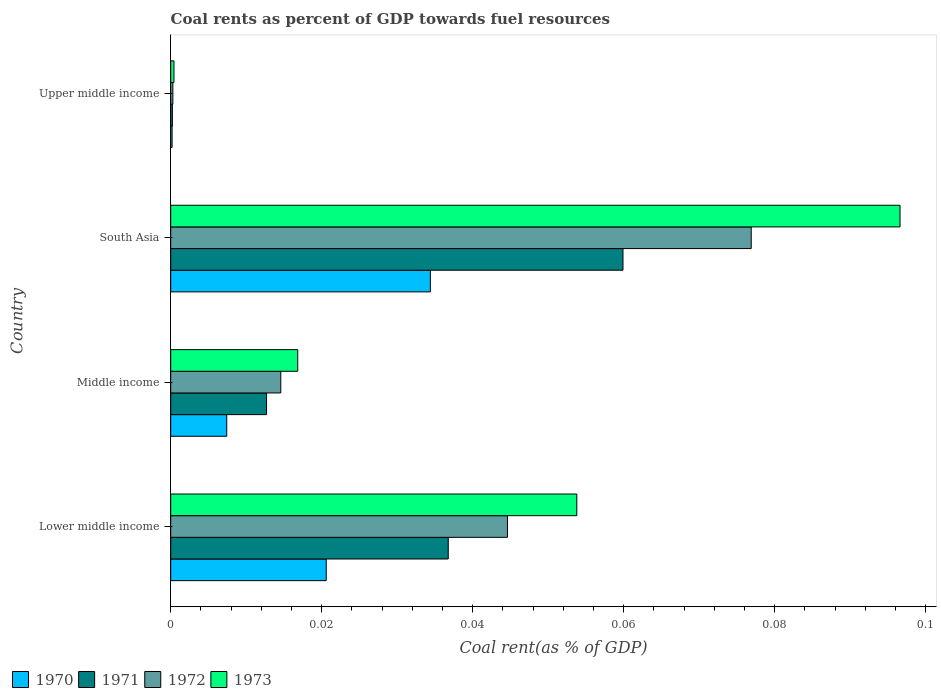How many different coloured bars are there?
Give a very brief answer. 4. How many groups of bars are there?
Your answer should be very brief. 4. Are the number of bars per tick equal to the number of legend labels?
Provide a short and direct response. Yes. How many bars are there on the 4th tick from the top?
Provide a succinct answer. 4. How many bars are there on the 4th tick from the bottom?
Keep it short and to the point. 4. What is the label of the 4th group of bars from the top?
Ensure brevity in your answer.  Lower middle income. What is the coal rent in 1973 in Upper middle income?
Provide a short and direct response. 0. Across all countries, what is the maximum coal rent in 1972?
Provide a succinct answer. 0.08. Across all countries, what is the minimum coal rent in 1971?
Give a very brief answer. 0. In which country was the coal rent in 1973 maximum?
Your answer should be very brief. South Asia. In which country was the coal rent in 1972 minimum?
Offer a very short reply. Upper middle income. What is the total coal rent in 1973 in the graph?
Provide a short and direct response. 0.17. What is the difference between the coal rent in 1971 in Lower middle income and that in Middle income?
Your answer should be compact. 0.02. What is the difference between the coal rent in 1971 in Lower middle income and the coal rent in 1972 in Middle income?
Your answer should be compact. 0.02. What is the average coal rent in 1972 per country?
Your answer should be very brief. 0.03. What is the difference between the coal rent in 1972 and coal rent in 1971 in Upper middle income?
Ensure brevity in your answer.  6.559434765832401e-5. What is the ratio of the coal rent in 1972 in Lower middle income to that in Upper middle income?
Your answer should be compact. 156.82. Is the coal rent in 1972 in South Asia less than that in Upper middle income?
Ensure brevity in your answer.  No. What is the difference between the highest and the second highest coal rent in 1971?
Your answer should be very brief. 0.02. What is the difference between the highest and the lowest coal rent in 1972?
Offer a terse response. 0.08. Is the sum of the coal rent in 1973 in Middle income and South Asia greater than the maximum coal rent in 1972 across all countries?
Provide a short and direct response. Yes. Are all the bars in the graph horizontal?
Keep it short and to the point. Yes. How many countries are there in the graph?
Offer a terse response. 4. Are the values on the major ticks of X-axis written in scientific E-notation?
Give a very brief answer. No. Does the graph contain any zero values?
Provide a short and direct response. No. Does the graph contain grids?
Keep it short and to the point. No. Where does the legend appear in the graph?
Provide a short and direct response. Bottom left. How are the legend labels stacked?
Provide a succinct answer. Horizontal. What is the title of the graph?
Make the answer very short. Coal rents as percent of GDP towards fuel resources. Does "1960" appear as one of the legend labels in the graph?
Provide a short and direct response. No. What is the label or title of the X-axis?
Make the answer very short. Coal rent(as % of GDP). What is the Coal rent(as % of GDP) in 1970 in Lower middle income?
Offer a terse response. 0.02. What is the Coal rent(as % of GDP) in 1971 in Lower middle income?
Provide a short and direct response. 0.04. What is the Coal rent(as % of GDP) of 1972 in Lower middle income?
Provide a succinct answer. 0.04. What is the Coal rent(as % of GDP) in 1973 in Lower middle income?
Make the answer very short. 0.05. What is the Coal rent(as % of GDP) in 1970 in Middle income?
Keep it short and to the point. 0.01. What is the Coal rent(as % of GDP) in 1971 in Middle income?
Your answer should be very brief. 0.01. What is the Coal rent(as % of GDP) in 1972 in Middle income?
Provide a succinct answer. 0.01. What is the Coal rent(as % of GDP) in 1973 in Middle income?
Provide a short and direct response. 0.02. What is the Coal rent(as % of GDP) of 1970 in South Asia?
Keep it short and to the point. 0.03. What is the Coal rent(as % of GDP) of 1971 in South Asia?
Keep it short and to the point. 0.06. What is the Coal rent(as % of GDP) of 1972 in South Asia?
Provide a short and direct response. 0.08. What is the Coal rent(as % of GDP) of 1973 in South Asia?
Your response must be concise. 0.1. What is the Coal rent(as % of GDP) in 1970 in Upper middle income?
Provide a succinct answer. 0. What is the Coal rent(as % of GDP) in 1971 in Upper middle income?
Give a very brief answer. 0. What is the Coal rent(as % of GDP) of 1972 in Upper middle income?
Give a very brief answer. 0. What is the Coal rent(as % of GDP) of 1973 in Upper middle income?
Your response must be concise. 0. Across all countries, what is the maximum Coal rent(as % of GDP) in 1970?
Give a very brief answer. 0.03. Across all countries, what is the maximum Coal rent(as % of GDP) of 1971?
Your answer should be very brief. 0.06. Across all countries, what is the maximum Coal rent(as % of GDP) in 1972?
Provide a short and direct response. 0.08. Across all countries, what is the maximum Coal rent(as % of GDP) of 1973?
Offer a very short reply. 0.1. Across all countries, what is the minimum Coal rent(as % of GDP) in 1970?
Offer a terse response. 0. Across all countries, what is the minimum Coal rent(as % of GDP) of 1971?
Make the answer very short. 0. Across all countries, what is the minimum Coal rent(as % of GDP) of 1972?
Offer a terse response. 0. Across all countries, what is the minimum Coal rent(as % of GDP) of 1973?
Ensure brevity in your answer.  0. What is the total Coal rent(as % of GDP) of 1970 in the graph?
Keep it short and to the point. 0.06. What is the total Coal rent(as % of GDP) in 1971 in the graph?
Your response must be concise. 0.11. What is the total Coal rent(as % of GDP) of 1972 in the graph?
Ensure brevity in your answer.  0.14. What is the total Coal rent(as % of GDP) of 1973 in the graph?
Your response must be concise. 0.17. What is the difference between the Coal rent(as % of GDP) in 1970 in Lower middle income and that in Middle income?
Your answer should be compact. 0.01. What is the difference between the Coal rent(as % of GDP) in 1971 in Lower middle income and that in Middle income?
Offer a terse response. 0.02. What is the difference between the Coal rent(as % of GDP) in 1973 in Lower middle income and that in Middle income?
Ensure brevity in your answer.  0.04. What is the difference between the Coal rent(as % of GDP) of 1970 in Lower middle income and that in South Asia?
Provide a succinct answer. -0.01. What is the difference between the Coal rent(as % of GDP) of 1971 in Lower middle income and that in South Asia?
Offer a very short reply. -0.02. What is the difference between the Coal rent(as % of GDP) of 1972 in Lower middle income and that in South Asia?
Offer a very short reply. -0.03. What is the difference between the Coal rent(as % of GDP) of 1973 in Lower middle income and that in South Asia?
Ensure brevity in your answer.  -0.04. What is the difference between the Coal rent(as % of GDP) in 1970 in Lower middle income and that in Upper middle income?
Keep it short and to the point. 0.02. What is the difference between the Coal rent(as % of GDP) of 1971 in Lower middle income and that in Upper middle income?
Offer a terse response. 0.04. What is the difference between the Coal rent(as % of GDP) in 1972 in Lower middle income and that in Upper middle income?
Provide a succinct answer. 0.04. What is the difference between the Coal rent(as % of GDP) of 1973 in Lower middle income and that in Upper middle income?
Offer a terse response. 0.05. What is the difference between the Coal rent(as % of GDP) in 1970 in Middle income and that in South Asia?
Provide a short and direct response. -0.03. What is the difference between the Coal rent(as % of GDP) of 1971 in Middle income and that in South Asia?
Your answer should be very brief. -0.05. What is the difference between the Coal rent(as % of GDP) in 1972 in Middle income and that in South Asia?
Ensure brevity in your answer.  -0.06. What is the difference between the Coal rent(as % of GDP) of 1973 in Middle income and that in South Asia?
Make the answer very short. -0.08. What is the difference between the Coal rent(as % of GDP) in 1970 in Middle income and that in Upper middle income?
Your answer should be very brief. 0.01. What is the difference between the Coal rent(as % of GDP) in 1971 in Middle income and that in Upper middle income?
Offer a very short reply. 0.01. What is the difference between the Coal rent(as % of GDP) of 1972 in Middle income and that in Upper middle income?
Ensure brevity in your answer.  0.01. What is the difference between the Coal rent(as % of GDP) in 1973 in Middle income and that in Upper middle income?
Provide a succinct answer. 0.02. What is the difference between the Coal rent(as % of GDP) in 1970 in South Asia and that in Upper middle income?
Ensure brevity in your answer.  0.03. What is the difference between the Coal rent(as % of GDP) of 1971 in South Asia and that in Upper middle income?
Make the answer very short. 0.06. What is the difference between the Coal rent(as % of GDP) in 1972 in South Asia and that in Upper middle income?
Offer a terse response. 0.08. What is the difference between the Coal rent(as % of GDP) in 1973 in South Asia and that in Upper middle income?
Provide a succinct answer. 0.1. What is the difference between the Coal rent(as % of GDP) of 1970 in Lower middle income and the Coal rent(as % of GDP) of 1971 in Middle income?
Your response must be concise. 0.01. What is the difference between the Coal rent(as % of GDP) in 1970 in Lower middle income and the Coal rent(as % of GDP) in 1972 in Middle income?
Keep it short and to the point. 0.01. What is the difference between the Coal rent(as % of GDP) of 1970 in Lower middle income and the Coal rent(as % of GDP) of 1973 in Middle income?
Give a very brief answer. 0. What is the difference between the Coal rent(as % of GDP) of 1971 in Lower middle income and the Coal rent(as % of GDP) of 1972 in Middle income?
Ensure brevity in your answer.  0.02. What is the difference between the Coal rent(as % of GDP) in 1971 in Lower middle income and the Coal rent(as % of GDP) in 1973 in Middle income?
Your response must be concise. 0.02. What is the difference between the Coal rent(as % of GDP) of 1972 in Lower middle income and the Coal rent(as % of GDP) of 1973 in Middle income?
Make the answer very short. 0.03. What is the difference between the Coal rent(as % of GDP) of 1970 in Lower middle income and the Coal rent(as % of GDP) of 1971 in South Asia?
Ensure brevity in your answer.  -0.04. What is the difference between the Coal rent(as % of GDP) in 1970 in Lower middle income and the Coal rent(as % of GDP) in 1972 in South Asia?
Offer a terse response. -0.06. What is the difference between the Coal rent(as % of GDP) of 1970 in Lower middle income and the Coal rent(as % of GDP) of 1973 in South Asia?
Provide a succinct answer. -0.08. What is the difference between the Coal rent(as % of GDP) in 1971 in Lower middle income and the Coal rent(as % of GDP) in 1972 in South Asia?
Provide a short and direct response. -0.04. What is the difference between the Coal rent(as % of GDP) of 1971 in Lower middle income and the Coal rent(as % of GDP) of 1973 in South Asia?
Your answer should be compact. -0.06. What is the difference between the Coal rent(as % of GDP) of 1972 in Lower middle income and the Coal rent(as % of GDP) of 1973 in South Asia?
Offer a terse response. -0.05. What is the difference between the Coal rent(as % of GDP) in 1970 in Lower middle income and the Coal rent(as % of GDP) in 1971 in Upper middle income?
Keep it short and to the point. 0.02. What is the difference between the Coal rent(as % of GDP) of 1970 in Lower middle income and the Coal rent(as % of GDP) of 1972 in Upper middle income?
Make the answer very short. 0.02. What is the difference between the Coal rent(as % of GDP) of 1970 in Lower middle income and the Coal rent(as % of GDP) of 1973 in Upper middle income?
Give a very brief answer. 0.02. What is the difference between the Coal rent(as % of GDP) of 1971 in Lower middle income and the Coal rent(as % of GDP) of 1972 in Upper middle income?
Offer a terse response. 0.04. What is the difference between the Coal rent(as % of GDP) in 1971 in Lower middle income and the Coal rent(as % of GDP) in 1973 in Upper middle income?
Provide a short and direct response. 0.04. What is the difference between the Coal rent(as % of GDP) of 1972 in Lower middle income and the Coal rent(as % of GDP) of 1973 in Upper middle income?
Provide a succinct answer. 0.04. What is the difference between the Coal rent(as % of GDP) in 1970 in Middle income and the Coal rent(as % of GDP) in 1971 in South Asia?
Offer a terse response. -0.05. What is the difference between the Coal rent(as % of GDP) of 1970 in Middle income and the Coal rent(as % of GDP) of 1972 in South Asia?
Give a very brief answer. -0.07. What is the difference between the Coal rent(as % of GDP) in 1970 in Middle income and the Coal rent(as % of GDP) in 1973 in South Asia?
Offer a very short reply. -0.09. What is the difference between the Coal rent(as % of GDP) in 1971 in Middle income and the Coal rent(as % of GDP) in 1972 in South Asia?
Offer a terse response. -0.06. What is the difference between the Coal rent(as % of GDP) of 1971 in Middle income and the Coal rent(as % of GDP) of 1973 in South Asia?
Provide a short and direct response. -0.08. What is the difference between the Coal rent(as % of GDP) in 1972 in Middle income and the Coal rent(as % of GDP) in 1973 in South Asia?
Offer a very short reply. -0.08. What is the difference between the Coal rent(as % of GDP) in 1970 in Middle income and the Coal rent(as % of GDP) in 1971 in Upper middle income?
Offer a very short reply. 0.01. What is the difference between the Coal rent(as % of GDP) in 1970 in Middle income and the Coal rent(as % of GDP) in 1972 in Upper middle income?
Your response must be concise. 0.01. What is the difference between the Coal rent(as % of GDP) of 1970 in Middle income and the Coal rent(as % of GDP) of 1973 in Upper middle income?
Offer a terse response. 0.01. What is the difference between the Coal rent(as % of GDP) of 1971 in Middle income and the Coal rent(as % of GDP) of 1972 in Upper middle income?
Ensure brevity in your answer.  0.01. What is the difference between the Coal rent(as % of GDP) in 1971 in Middle income and the Coal rent(as % of GDP) in 1973 in Upper middle income?
Offer a very short reply. 0.01. What is the difference between the Coal rent(as % of GDP) of 1972 in Middle income and the Coal rent(as % of GDP) of 1973 in Upper middle income?
Your answer should be very brief. 0.01. What is the difference between the Coal rent(as % of GDP) of 1970 in South Asia and the Coal rent(as % of GDP) of 1971 in Upper middle income?
Ensure brevity in your answer.  0.03. What is the difference between the Coal rent(as % of GDP) of 1970 in South Asia and the Coal rent(as % of GDP) of 1972 in Upper middle income?
Offer a very short reply. 0.03. What is the difference between the Coal rent(as % of GDP) in 1970 in South Asia and the Coal rent(as % of GDP) in 1973 in Upper middle income?
Ensure brevity in your answer.  0.03. What is the difference between the Coal rent(as % of GDP) of 1971 in South Asia and the Coal rent(as % of GDP) of 1972 in Upper middle income?
Your response must be concise. 0.06. What is the difference between the Coal rent(as % of GDP) in 1971 in South Asia and the Coal rent(as % of GDP) in 1973 in Upper middle income?
Provide a succinct answer. 0.06. What is the difference between the Coal rent(as % of GDP) in 1972 in South Asia and the Coal rent(as % of GDP) in 1973 in Upper middle income?
Offer a very short reply. 0.08. What is the average Coal rent(as % of GDP) of 1970 per country?
Provide a succinct answer. 0.02. What is the average Coal rent(as % of GDP) of 1971 per country?
Provide a short and direct response. 0.03. What is the average Coal rent(as % of GDP) in 1972 per country?
Your response must be concise. 0.03. What is the average Coal rent(as % of GDP) of 1973 per country?
Provide a succinct answer. 0.04. What is the difference between the Coal rent(as % of GDP) in 1970 and Coal rent(as % of GDP) in 1971 in Lower middle income?
Ensure brevity in your answer.  -0.02. What is the difference between the Coal rent(as % of GDP) of 1970 and Coal rent(as % of GDP) of 1972 in Lower middle income?
Your answer should be very brief. -0.02. What is the difference between the Coal rent(as % of GDP) of 1970 and Coal rent(as % of GDP) of 1973 in Lower middle income?
Your answer should be compact. -0.03. What is the difference between the Coal rent(as % of GDP) of 1971 and Coal rent(as % of GDP) of 1972 in Lower middle income?
Your answer should be compact. -0.01. What is the difference between the Coal rent(as % of GDP) in 1971 and Coal rent(as % of GDP) in 1973 in Lower middle income?
Make the answer very short. -0.02. What is the difference between the Coal rent(as % of GDP) in 1972 and Coal rent(as % of GDP) in 1973 in Lower middle income?
Your answer should be compact. -0.01. What is the difference between the Coal rent(as % of GDP) of 1970 and Coal rent(as % of GDP) of 1971 in Middle income?
Make the answer very short. -0.01. What is the difference between the Coal rent(as % of GDP) of 1970 and Coal rent(as % of GDP) of 1972 in Middle income?
Offer a terse response. -0.01. What is the difference between the Coal rent(as % of GDP) of 1970 and Coal rent(as % of GDP) of 1973 in Middle income?
Your response must be concise. -0.01. What is the difference between the Coal rent(as % of GDP) in 1971 and Coal rent(as % of GDP) in 1972 in Middle income?
Offer a terse response. -0. What is the difference between the Coal rent(as % of GDP) of 1971 and Coal rent(as % of GDP) of 1973 in Middle income?
Your answer should be compact. -0. What is the difference between the Coal rent(as % of GDP) of 1972 and Coal rent(as % of GDP) of 1973 in Middle income?
Make the answer very short. -0. What is the difference between the Coal rent(as % of GDP) in 1970 and Coal rent(as % of GDP) in 1971 in South Asia?
Your answer should be compact. -0.03. What is the difference between the Coal rent(as % of GDP) of 1970 and Coal rent(as % of GDP) of 1972 in South Asia?
Make the answer very short. -0.04. What is the difference between the Coal rent(as % of GDP) of 1970 and Coal rent(as % of GDP) of 1973 in South Asia?
Offer a terse response. -0.06. What is the difference between the Coal rent(as % of GDP) of 1971 and Coal rent(as % of GDP) of 1972 in South Asia?
Your answer should be very brief. -0.02. What is the difference between the Coal rent(as % of GDP) of 1971 and Coal rent(as % of GDP) of 1973 in South Asia?
Give a very brief answer. -0.04. What is the difference between the Coal rent(as % of GDP) in 1972 and Coal rent(as % of GDP) in 1973 in South Asia?
Give a very brief answer. -0.02. What is the difference between the Coal rent(as % of GDP) of 1970 and Coal rent(as % of GDP) of 1972 in Upper middle income?
Your answer should be very brief. -0. What is the difference between the Coal rent(as % of GDP) of 1970 and Coal rent(as % of GDP) of 1973 in Upper middle income?
Offer a terse response. -0. What is the difference between the Coal rent(as % of GDP) in 1971 and Coal rent(as % of GDP) in 1972 in Upper middle income?
Ensure brevity in your answer.  -0. What is the difference between the Coal rent(as % of GDP) of 1971 and Coal rent(as % of GDP) of 1973 in Upper middle income?
Your answer should be very brief. -0. What is the difference between the Coal rent(as % of GDP) in 1972 and Coal rent(as % of GDP) in 1973 in Upper middle income?
Make the answer very short. -0. What is the ratio of the Coal rent(as % of GDP) of 1970 in Lower middle income to that in Middle income?
Keep it short and to the point. 2.78. What is the ratio of the Coal rent(as % of GDP) in 1971 in Lower middle income to that in Middle income?
Ensure brevity in your answer.  2.9. What is the ratio of the Coal rent(as % of GDP) of 1972 in Lower middle income to that in Middle income?
Ensure brevity in your answer.  3.06. What is the ratio of the Coal rent(as % of GDP) in 1973 in Lower middle income to that in Middle income?
Your response must be concise. 3.2. What is the ratio of the Coal rent(as % of GDP) of 1970 in Lower middle income to that in South Asia?
Give a very brief answer. 0.6. What is the ratio of the Coal rent(as % of GDP) of 1971 in Lower middle income to that in South Asia?
Give a very brief answer. 0.61. What is the ratio of the Coal rent(as % of GDP) of 1972 in Lower middle income to that in South Asia?
Offer a terse response. 0.58. What is the ratio of the Coal rent(as % of GDP) in 1973 in Lower middle income to that in South Asia?
Provide a short and direct response. 0.56. What is the ratio of the Coal rent(as % of GDP) in 1970 in Lower middle income to that in Upper middle income?
Your answer should be very brief. 112.03. What is the ratio of the Coal rent(as % of GDP) of 1971 in Lower middle income to that in Upper middle income?
Provide a short and direct response. 167.98. What is the ratio of the Coal rent(as % of GDP) in 1972 in Lower middle income to that in Upper middle income?
Give a very brief answer. 156.82. What is the ratio of the Coal rent(as % of GDP) of 1973 in Lower middle income to that in Upper middle income?
Provide a succinct answer. 124.82. What is the ratio of the Coal rent(as % of GDP) of 1970 in Middle income to that in South Asia?
Your answer should be very brief. 0.22. What is the ratio of the Coal rent(as % of GDP) of 1971 in Middle income to that in South Asia?
Your answer should be compact. 0.21. What is the ratio of the Coal rent(as % of GDP) of 1972 in Middle income to that in South Asia?
Keep it short and to the point. 0.19. What is the ratio of the Coal rent(as % of GDP) of 1973 in Middle income to that in South Asia?
Provide a succinct answer. 0.17. What is the ratio of the Coal rent(as % of GDP) in 1970 in Middle income to that in Upper middle income?
Provide a succinct answer. 40.36. What is the ratio of the Coal rent(as % of GDP) of 1971 in Middle income to that in Upper middle income?
Your answer should be compact. 58.01. What is the ratio of the Coal rent(as % of GDP) in 1972 in Middle income to that in Upper middle income?
Provide a short and direct response. 51.25. What is the ratio of the Coal rent(as % of GDP) in 1973 in Middle income to that in Upper middle income?
Your answer should be very brief. 39.04. What is the ratio of the Coal rent(as % of GDP) of 1970 in South Asia to that in Upper middle income?
Your answer should be compact. 187.05. What is the ratio of the Coal rent(as % of GDP) of 1971 in South Asia to that in Upper middle income?
Make the answer very short. 273.74. What is the ratio of the Coal rent(as % of GDP) of 1972 in South Asia to that in Upper middle income?
Your response must be concise. 270.32. What is the ratio of the Coal rent(as % of GDP) of 1973 in South Asia to that in Upper middle income?
Provide a succinct answer. 224.18. What is the difference between the highest and the second highest Coal rent(as % of GDP) of 1970?
Your answer should be very brief. 0.01. What is the difference between the highest and the second highest Coal rent(as % of GDP) in 1971?
Offer a terse response. 0.02. What is the difference between the highest and the second highest Coal rent(as % of GDP) of 1972?
Offer a terse response. 0.03. What is the difference between the highest and the second highest Coal rent(as % of GDP) in 1973?
Provide a succinct answer. 0.04. What is the difference between the highest and the lowest Coal rent(as % of GDP) in 1970?
Your answer should be compact. 0.03. What is the difference between the highest and the lowest Coal rent(as % of GDP) in 1971?
Your answer should be compact. 0.06. What is the difference between the highest and the lowest Coal rent(as % of GDP) in 1972?
Ensure brevity in your answer.  0.08. What is the difference between the highest and the lowest Coal rent(as % of GDP) of 1973?
Ensure brevity in your answer.  0.1. 